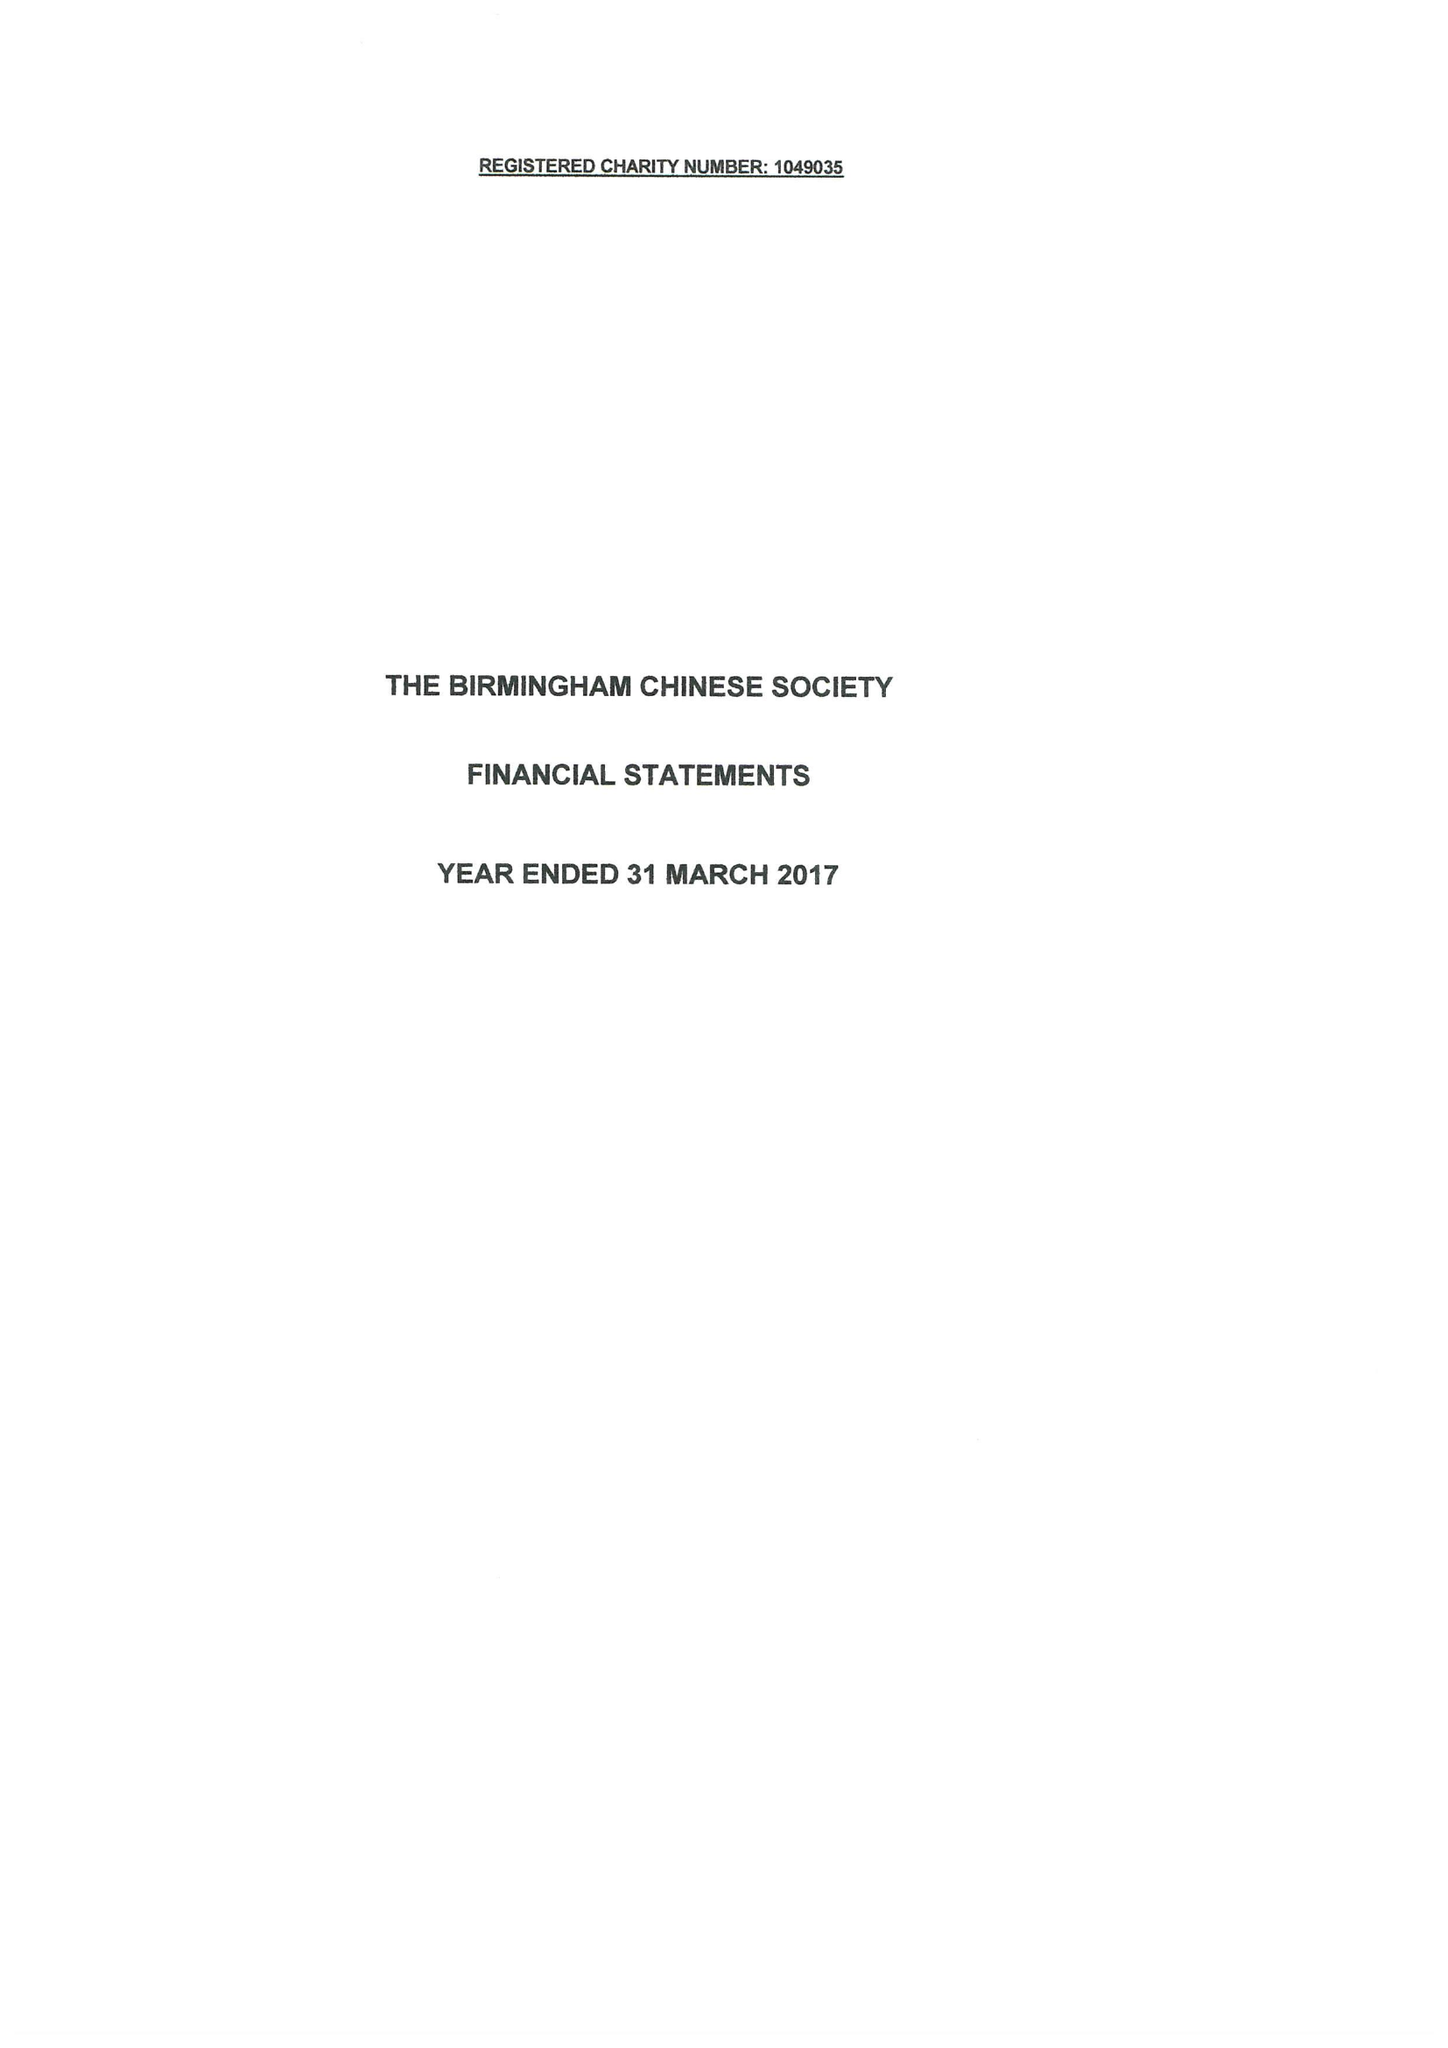What is the value for the address__post_town?
Answer the question using a single word or phrase. BIRMINGHAM 